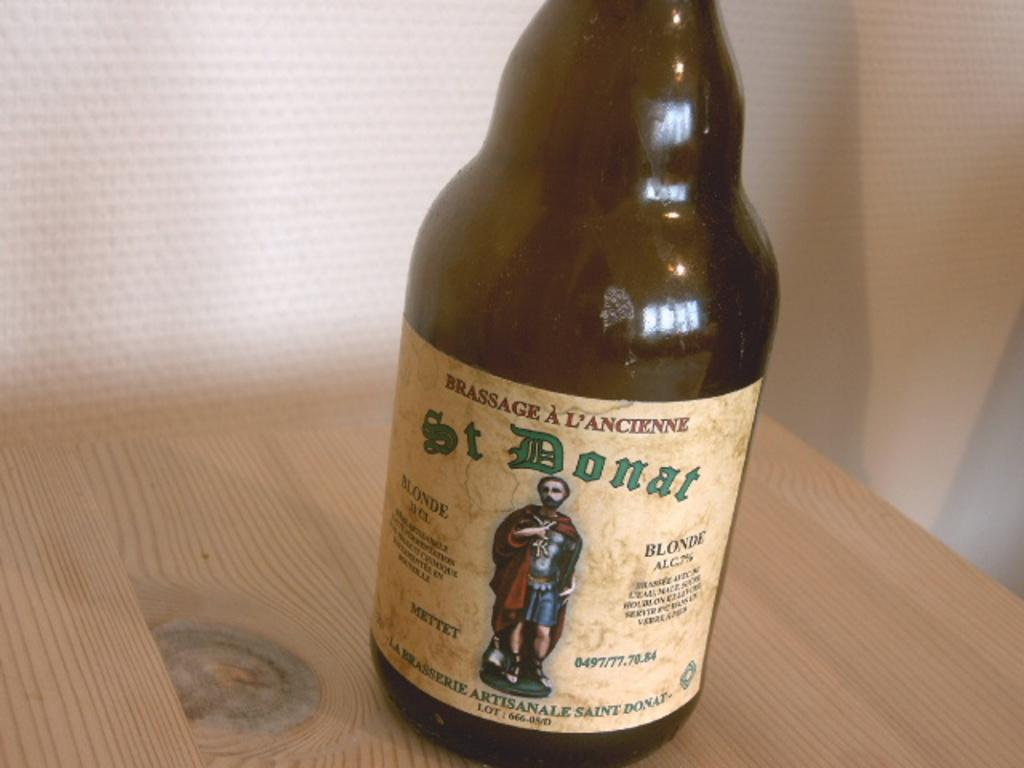<image>
Describe the image concisely. An empty bottle of St. Donat, blonde ale is on a wooden surface. 